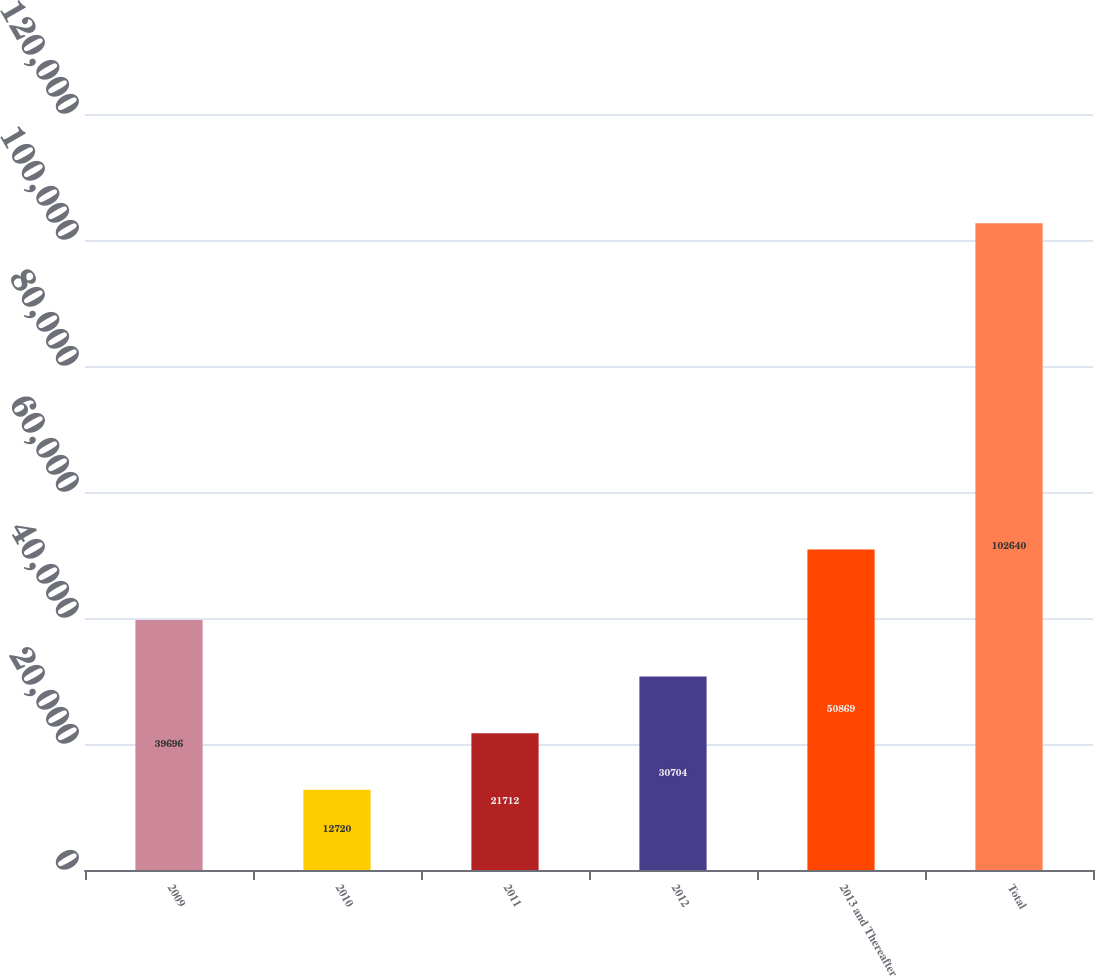<chart> <loc_0><loc_0><loc_500><loc_500><bar_chart><fcel>2009<fcel>2010<fcel>2011<fcel>2012<fcel>2013 and Thereafter<fcel>Total<nl><fcel>39696<fcel>12720<fcel>21712<fcel>30704<fcel>50869<fcel>102640<nl></chart> 